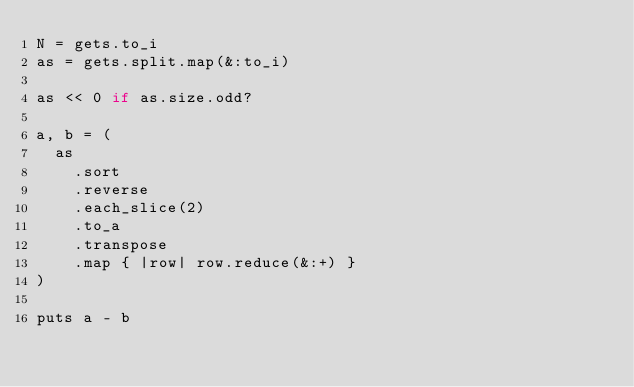<code> <loc_0><loc_0><loc_500><loc_500><_Ruby_>N = gets.to_i
as = gets.split.map(&:to_i)

as << 0 if as.size.odd?

a, b = (
  as
    .sort
    .reverse
    .each_slice(2)
    .to_a
    .transpose
    .map { |row| row.reduce(&:+) }
)

puts a - b
</code> 